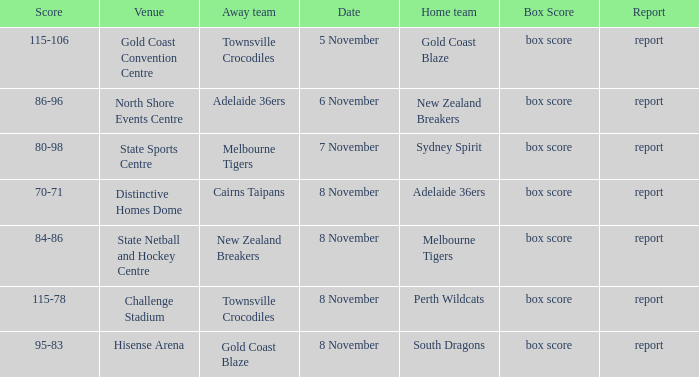Who was the home team at Gold Coast Convention Centre? Gold Coast Blaze. 